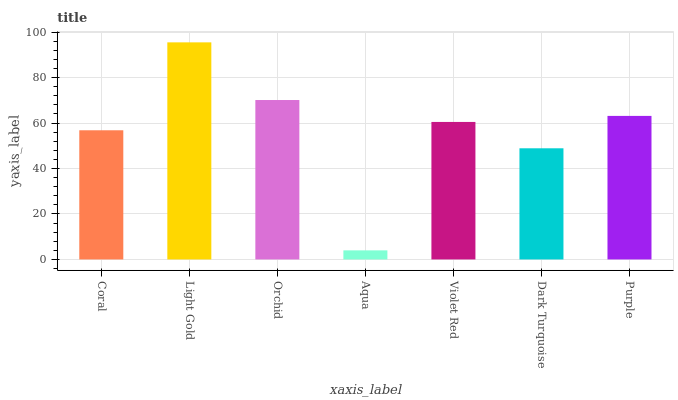Is Aqua the minimum?
Answer yes or no. Yes. Is Light Gold the maximum?
Answer yes or no. Yes. Is Orchid the minimum?
Answer yes or no. No. Is Orchid the maximum?
Answer yes or no. No. Is Light Gold greater than Orchid?
Answer yes or no. Yes. Is Orchid less than Light Gold?
Answer yes or no. Yes. Is Orchid greater than Light Gold?
Answer yes or no. No. Is Light Gold less than Orchid?
Answer yes or no. No. Is Violet Red the high median?
Answer yes or no. Yes. Is Violet Red the low median?
Answer yes or no. Yes. Is Dark Turquoise the high median?
Answer yes or no. No. Is Orchid the low median?
Answer yes or no. No. 